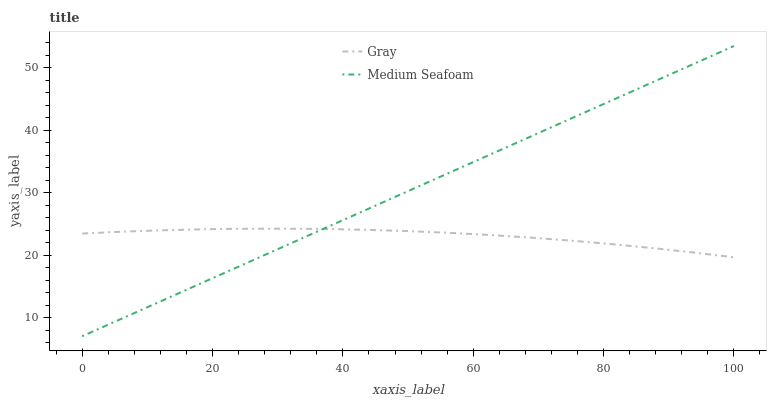Does Gray have the minimum area under the curve?
Answer yes or no. Yes. Does Medium Seafoam have the maximum area under the curve?
Answer yes or no. Yes. Does Medium Seafoam have the minimum area under the curve?
Answer yes or no. No. Is Medium Seafoam the smoothest?
Answer yes or no. Yes. Is Gray the roughest?
Answer yes or no. Yes. Is Medium Seafoam the roughest?
Answer yes or no. No. Does Medium Seafoam have the lowest value?
Answer yes or no. Yes. Does Medium Seafoam have the highest value?
Answer yes or no. Yes. Does Medium Seafoam intersect Gray?
Answer yes or no. Yes. Is Medium Seafoam less than Gray?
Answer yes or no. No. Is Medium Seafoam greater than Gray?
Answer yes or no. No. 